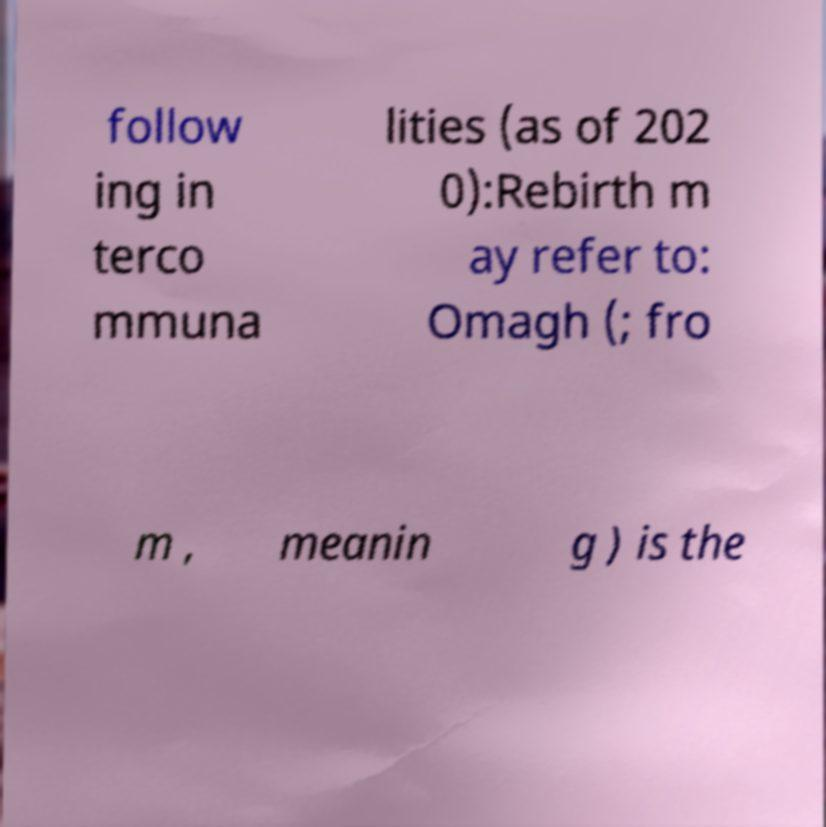I need the written content from this picture converted into text. Can you do that? follow ing in terco mmuna lities (as of 202 0):Rebirth m ay refer to: Omagh (; fro m , meanin g ) is the 